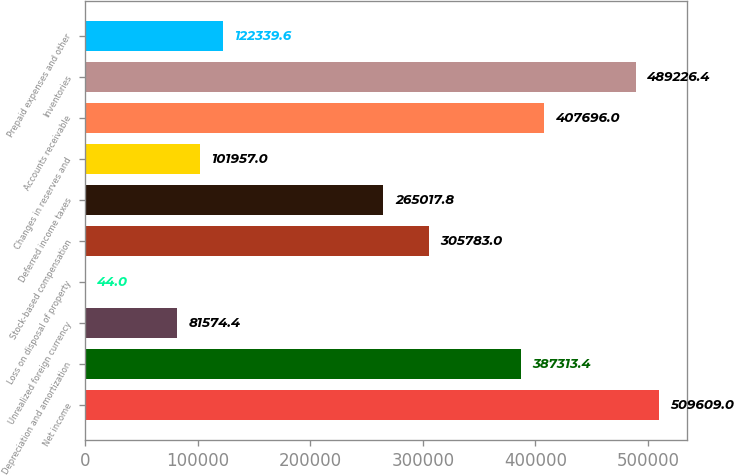Convert chart to OTSL. <chart><loc_0><loc_0><loc_500><loc_500><bar_chart><fcel>Net income<fcel>Depreciation and amortization<fcel>Unrealized foreign currency<fcel>Loss on disposal of property<fcel>Stock-based compensation<fcel>Deferred income taxes<fcel>Changes in reserves and<fcel>Accounts receivable<fcel>Inventories<fcel>Prepaid expenses and other<nl><fcel>509609<fcel>387313<fcel>81574.4<fcel>44<fcel>305783<fcel>265018<fcel>101957<fcel>407696<fcel>489226<fcel>122340<nl></chart> 